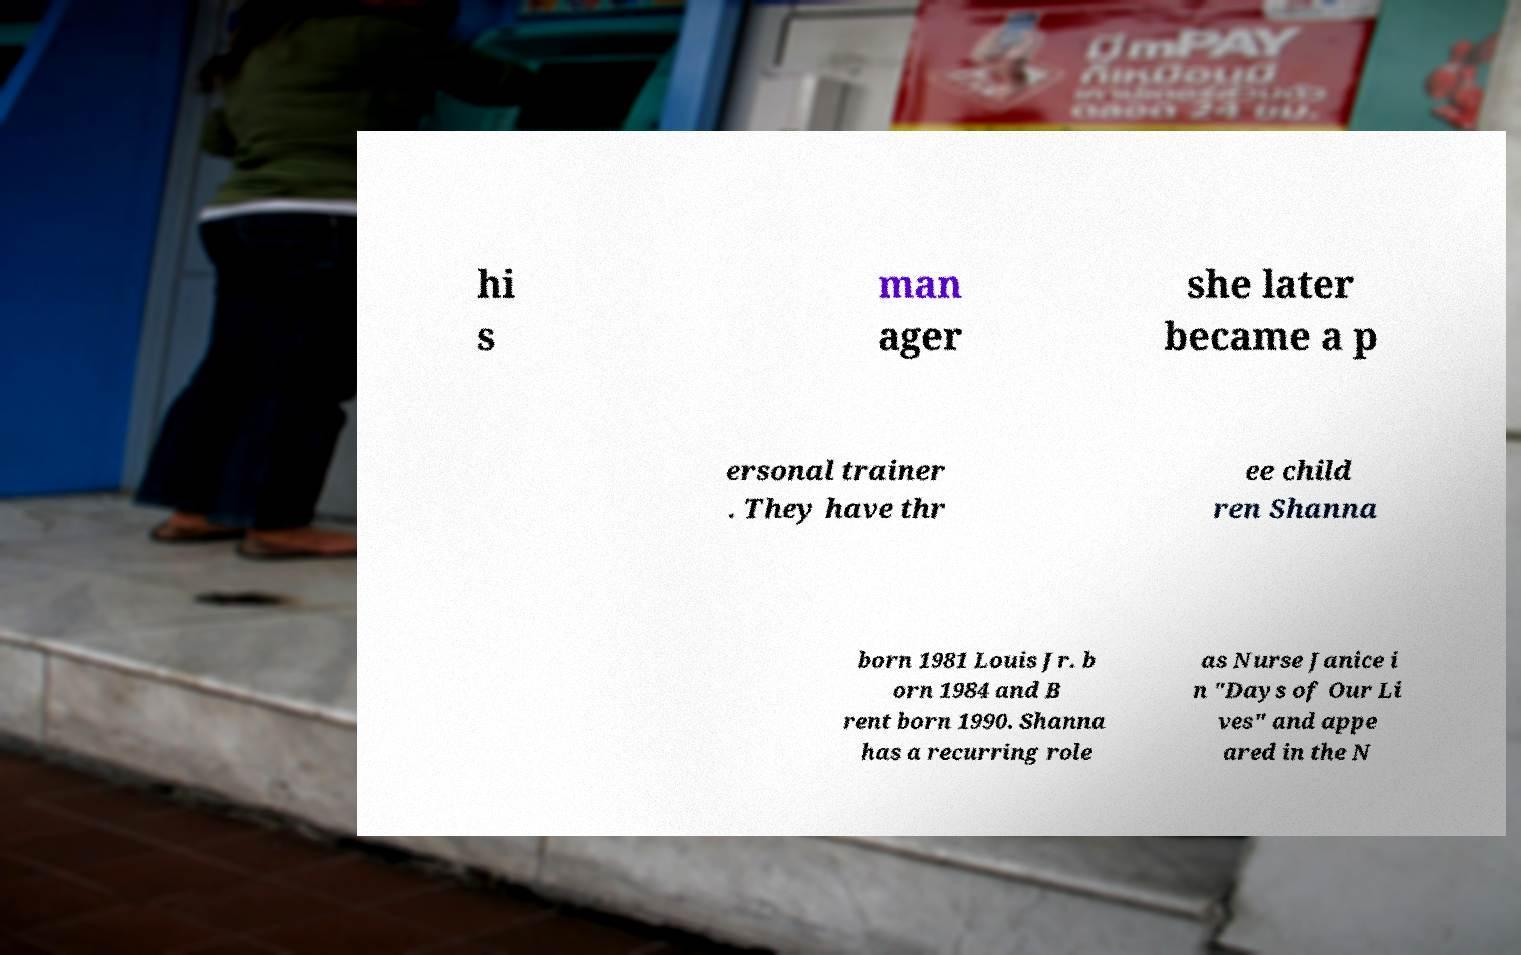Please read and relay the text visible in this image. What does it say? hi s man ager she later became a p ersonal trainer . They have thr ee child ren Shanna born 1981 Louis Jr. b orn 1984 and B rent born 1990. Shanna has a recurring role as Nurse Janice i n "Days of Our Li ves" and appe ared in the N 